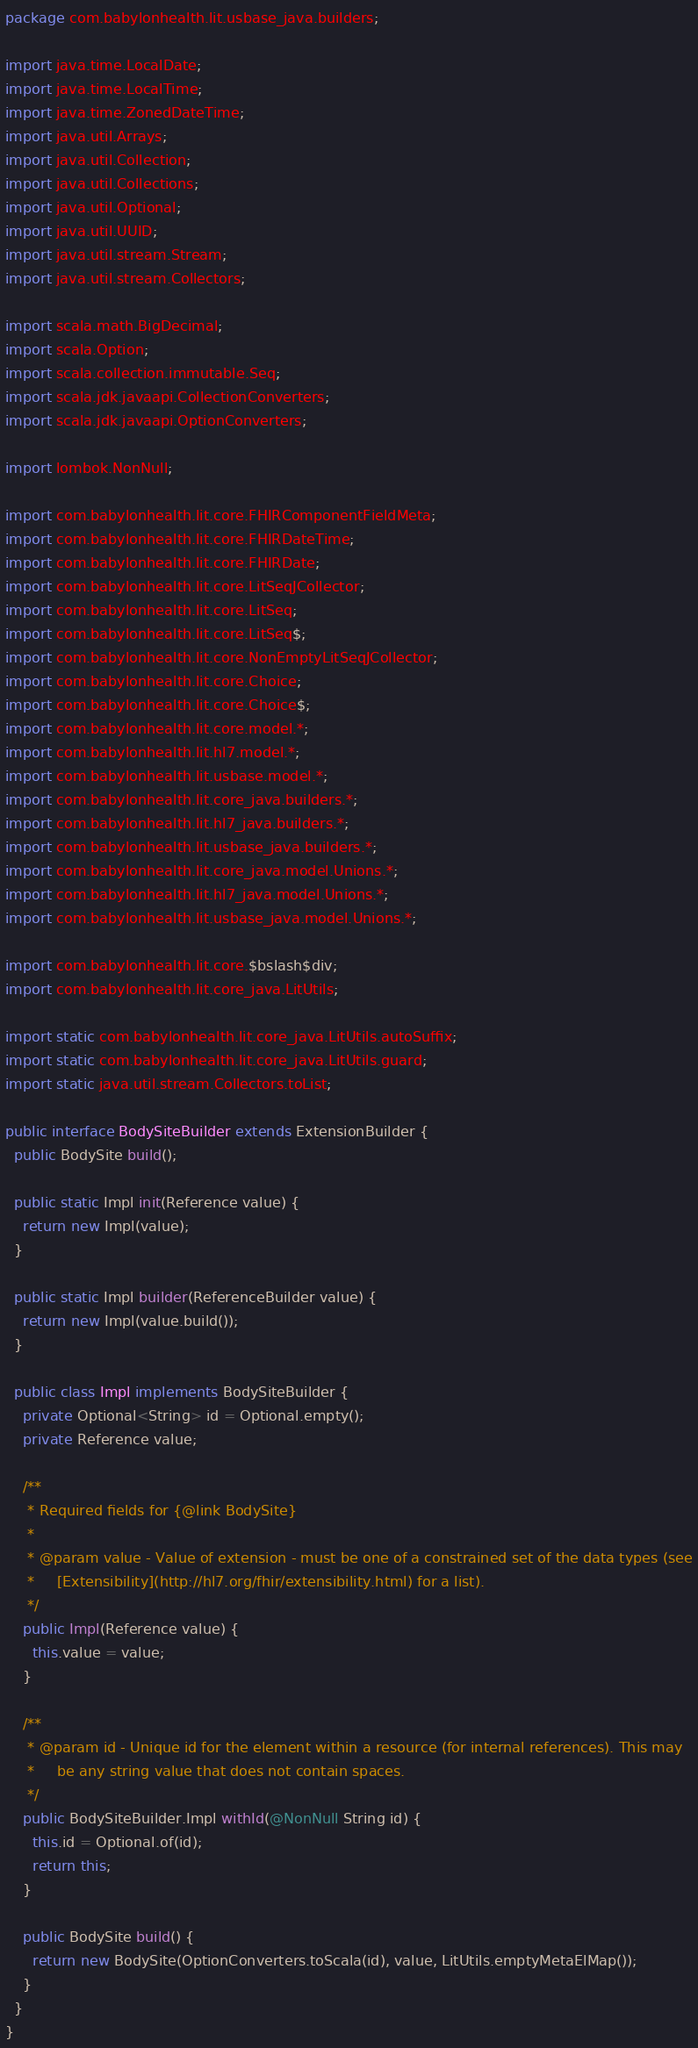Convert code to text. <code><loc_0><loc_0><loc_500><loc_500><_Java_>package com.babylonhealth.lit.usbase_java.builders;

import java.time.LocalDate;
import java.time.LocalTime;
import java.time.ZonedDateTime;
import java.util.Arrays;
import java.util.Collection;
import java.util.Collections;
import java.util.Optional;
import java.util.UUID;
import java.util.stream.Stream;
import java.util.stream.Collectors;

import scala.math.BigDecimal;
import scala.Option;
import scala.collection.immutable.Seq;
import scala.jdk.javaapi.CollectionConverters;
import scala.jdk.javaapi.OptionConverters;

import lombok.NonNull;

import com.babylonhealth.lit.core.FHIRComponentFieldMeta;
import com.babylonhealth.lit.core.FHIRDateTime;
import com.babylonhealth.lit.core.FHIRDate;
import com.babylonhealth.lit.core.LitSeqJCollector;
import com.babylonhealth.lit.core.LitSeq;
import com.babylonhealth.lit.core.LitSeq$;
import com.babylonhealth.lit.core.NonEmptyLitSeqJCollector;
import com.babylonhealth.lit.core.Choice;
import com.babylonhealth.lit.core.Choice$;
import com.babylonhealth.lit.core.model.*;
import com.babylonhealth.lit.hl7.model.*;
import com.babylonhealth.lit.usbase.model.*;
import com.babylonhealth.lit.core_java.builders.*;
import com.babylonhealth.lit.hl7_java.builders.*;
import com.babylonhealth.lit.usbase_java.builders.*;
import com.babylonhealth.lit.core_java.model.Unions.*;
import com.babylonhealth.lit.hl7_java.model.Unions.*;
import com.babylonhealth.lit.usbase_java.model.Unions.*;

import com.babylonhealth.lit.core.$bslash$div;
import com.babylonhealth.lit.core_java.LitUtils;

import static com.babylonhealth.lit.core_java.LitUtils.autoSuffix;
import static com.babylonhealth.lit.core_java.LitUtils.guard;
import static java.util.stream.Collectors.toList;

public interface BodySiteBuilder extends ExtensionBuilder {
  public BodySite build();

  public static Impl init(Reference value) {
    return new Impl(value);
  }

  public static Impl builder(ReferenceBuilder value) {
    return new Impl(value.build());
  }

  public class Impl implements BodySiteBuilder {
    private Optional<String> id = Optional.empty();
    private Reference value;

    /**
     * Required fields for {@link BodySite}
     *
     * @param value - Value of extension - must be one of a constrained set of the data types (see
     *     [Extensibility](http://hl7.org/fhir/extensibility.html) for a list).
     */
    public Impl(Reference value) {
      this.value = value;
    }

    /**
     * @param id - Unique id for the element within a resource (for internal references). This may
     *     be any string value that does not contain spaces.
     */
    public BodySiteBuilder.Impl withId(@NonNull String id) {
      this.id = Optional.of(id);
      return this;
    }

    public BodySite build() {
      return new BodySite(OptionConverters.toScala(id), value, LitUtils.emptyMetaElMap());
    }
  }
}
</code> 